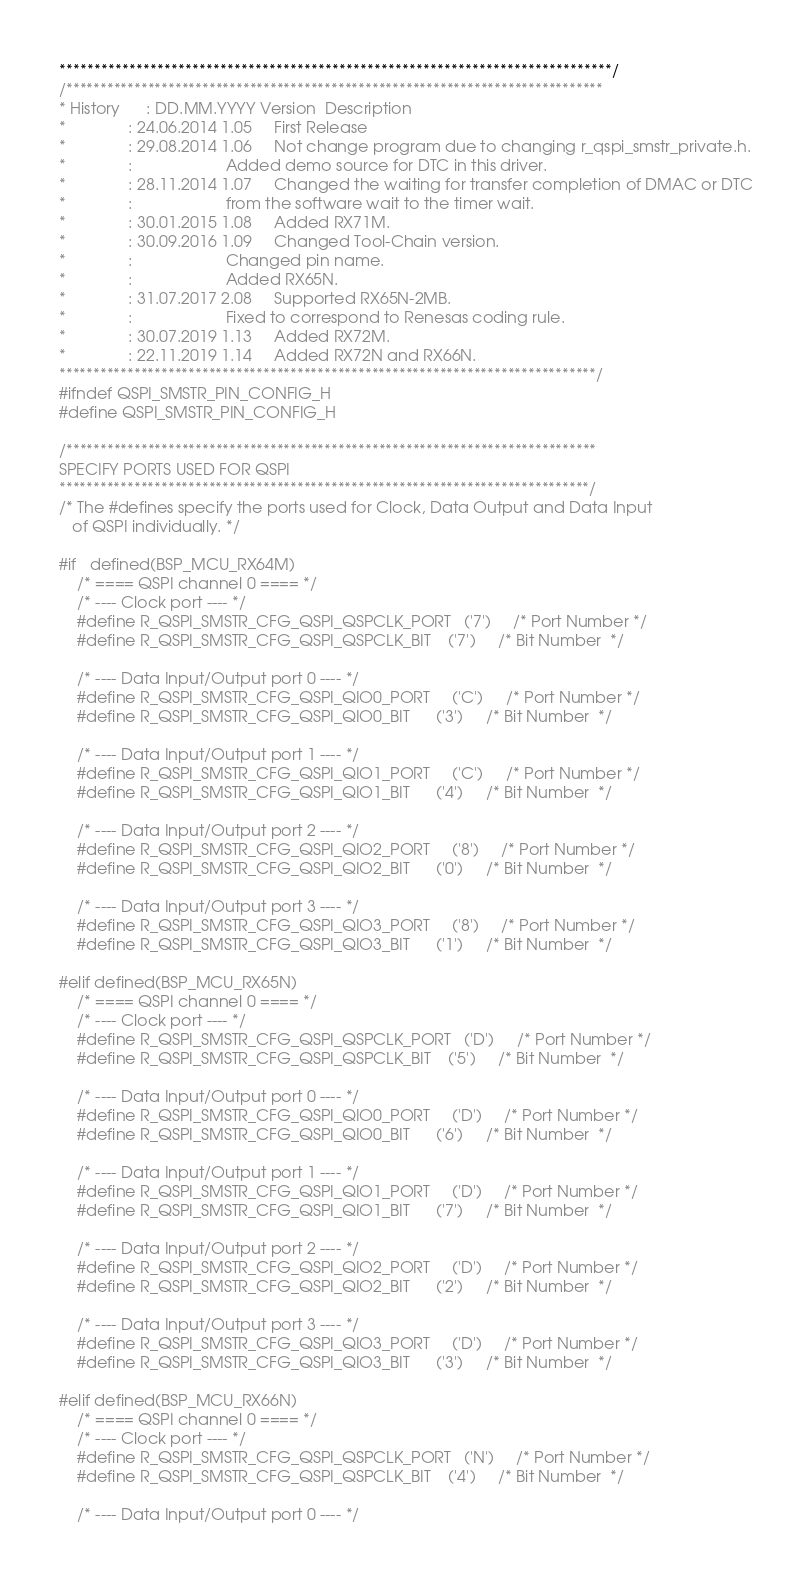Convert code to text. <code><loc_0><loc_0><loc_500><loc_500><_C_>*******************************************************************************/
/*******************************************************************************
* History      : DD.MM.YYYY Version  Description
*              : 24.06.2014 1.05     First Release
*              : 29.08.2014 1.06     Not change program due to changing r_qspi_smstr_private.h.
*              :                     Added demo source for DTC in this driver.
*              : 28.11.2014 1.07     Changed the waiting for transfer completion of DMAC or DTC
*              :                     from the software wait to the timer wait.
*              : 30.01.2015 1.08     Added RX71M.
*              : 30.09.2016 1.09     Changed Tool-Chain version.
*              :                     Changed pin name.
*              :                     Added RX65N.
*              : 31.07.2017 2.08     Supported RX65N-2MB.
*              :                     Fixed to correspond to Renesas coding rule.
*              : 30.07.2019 1.13     Added RX72M.
*              : 22.11.2019 1.14     Added RX72N and RX66N.
*******************************************************************************/
#ifndef QSPI_SMSTR_PIN_CONFIG_H
#define QSPI_SMSTR_PIN_CONFIG_H

/******************************************************************************
SPECIFY PORTS USED FOR QSPI
******************************************************************************/
/* The #defines specify the ports used for Clock, Data Output and Data Input
   of QSPI individually. */

#if   defined(BSP_MCU_RX64M)
    /* ==== QSPI channel 0 ==== */
    /* ---- Clock port ---- */
    #define R_QSPI_SMSTR_CFG_QSPI_QSPCLK_PORT   ('7')     /* Port Number */
    #define R_QSPI_SMSTR_CFG_QSPI_QSPCLK_BIT    ('7')     /* Bit Number  */

    /* ---- Data Input/Output port 0 ---- */
    #define R_QSPI_SMSTR_CFG_QSPI_QIO0_PORT     ('C')     /* Port Number */
    #define R_QSPI_SMSTR_CFG_QSPI_QIO0_BIT      ('3')     /* Bit Number  */

    /* ---- Data Input/Output port 1 ---- */
    #define R_QSPI_SMSTR_CFG_QSPI_QIO1_PORT     ('C')     /* Port Number */
    #define R_QSPI_SMSTR_CFG_QSPI_QIO1_BIT      ('4')     /* Bit Number  */

    /* ---- Data Input/Output port 2 ---- */
    #define R_QSPI_SMSTR_CFG_QSPI_QIO2_PORT     ('8')     /* Port Number */
    #define R_QSPI_SMSTR_CFG_QSPI_QIO2_BIT      ('0')     /* Bit Number  */

    /* ---- Data Input/Output port 3 ---- */
    #define R_QSPI_SMSTR_CFG_QSPI_QIO3_PORT     ('8')     /* Port Number */
    #define R_QSPI_SMSTR_CFG_QSPI_QIO3_BIT      ('1')     /* Bit Number  */

#elif defined(BSP_MCU_RX65N)
    /* ==== QSPI channel 0 ==== */
    /* ---- Clock port ---- */
    #define R_QSPI_SMSTR_CFG_QSPI_QSPCLK_PORT   ('D')     /* Port Number */
    #define R_QSPI_SMSTR_CFG_QSPI_QSPCLK_BIT    ('5')     /* Bit Number  */

    /* ---- Data Input/Output port 0 ---- */
    #define R_QSPI_SMSTR_CFG_QSPI_QIO0_PORT     ('D')     /* Port Number */
    #define R_QSPI_SMSTR_CFG_QSPI_QIO0_BIT      ('6')     /* Bit Number  */

    /* ---- Data Input/Output port 1 ---- */
    #define R_QSPI_SMSTR_CFG_QSPI_QIO1_PORT     ('D')     /* Port Number */
    #define R_QSPI_SMSTR_CFG_QSPI_QIO1_BIT      ('7')     /* Bit Number  */

    /* ---- Data Input/Output port 2 ---- */
    #define R_QSPI_SMSTR_CFG_QSPI_QIO2_PORT     ('D')     /* Port Number */
    #define R_QSPI_SMSTR_CFG_QSPI_QIO2_BIT      ('2')     /* Bit Number  */

    /* ---- Data Input/Output port 3 ---- */
    #define R_QSPI_SMSTR_CFG_QSPI_QIO3_PORT     ('D')     /* Port Number */
    #define R_QSPI_SMSTR_CFG_QSPI_QIO3_BIT      ('3')     /* Bit Number  */

#elif defined(BSP_MCU_RX66N)
    /* ==== QSPI channel 0 ==== */
    /* ---- Clock port ---- */
    #define R_QSPI_SMSTR_CFG_QSPI_QSPCLK_PORT   ('N')     /* Port Number */
    #define R_QSPI_SMSTR_CFG_QSPI_QSPCLK_BIT    ('4')     /* Bit Number  */

    /* ---- Data Input/Output port 0 ---- */</code> 